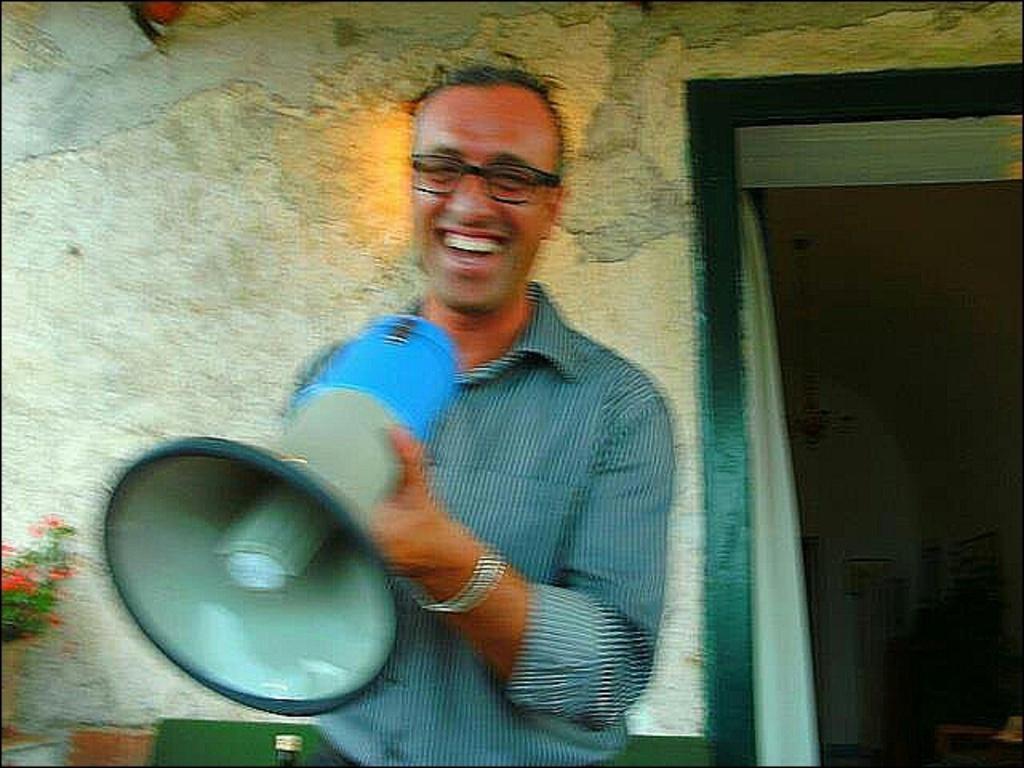Please provide a concise description of this image. In the image we can see there is a man standing and he is holding a loudspeaker mic in his hand. Behind there are flowers kept in the vase and there is wall. 